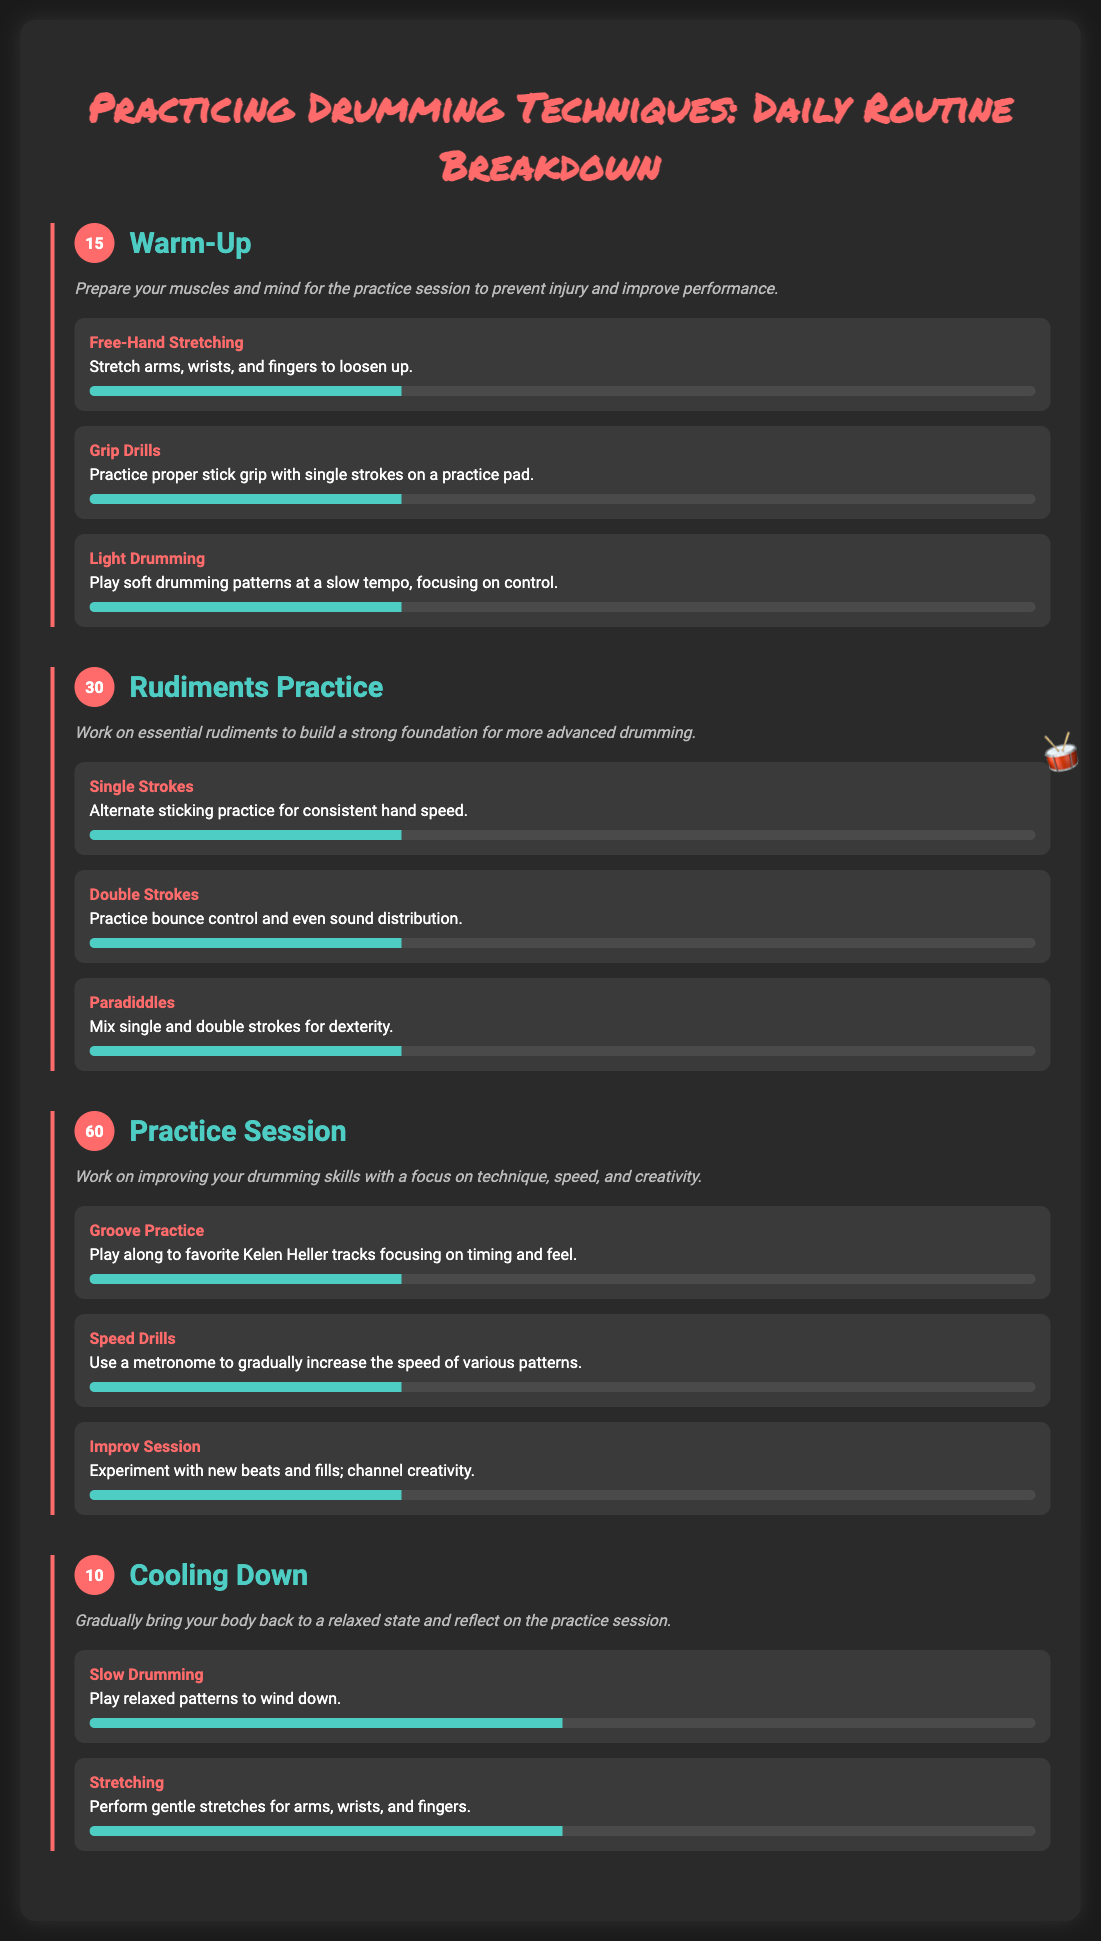What is the total time allocated for warm-up? The total time for warm-up is specified under the section title, which is 15 minutes.
Answer: 15 How many rudiments are practiced in the section? There are three rudiments mentioned under the Rudiments Practice section, listed as Single Strokes, Double Strokes, and Paradiddles.
Answer: 3 What is the duration of the Practice Session? The duration of the Practice Session is indicated in the section title, which is 60 minutes.
Answer: 60 Which exercise focuses on timing and feel? The Groove Practice exercise is highlighted for focusing on timing and feel.
Answer: Groove Practice What percentage progress is shown for Slow Drumming? The progress bar for Slow Drumming indicates a 50% completion.
Answer: 50% What type of drills are practiced to improve bounce control? Double Strokes drills are specified for improving bounce control.
Answer: Double Strokes What activity is suggested for cooling down? Slow Drumming and Stretching are the activities suggested for cooling down.
Answer: Slow Drumming What is the main objective of the Warm-Up section? The main objective is to prepare muscles and mind for the practice session.
Answer: Prepare muscles and mind What is the description for the Improv Session? The Improv Session is described as an opportunity to experiment with new beats and fills.
Answer: Experiment with new beats and fills 